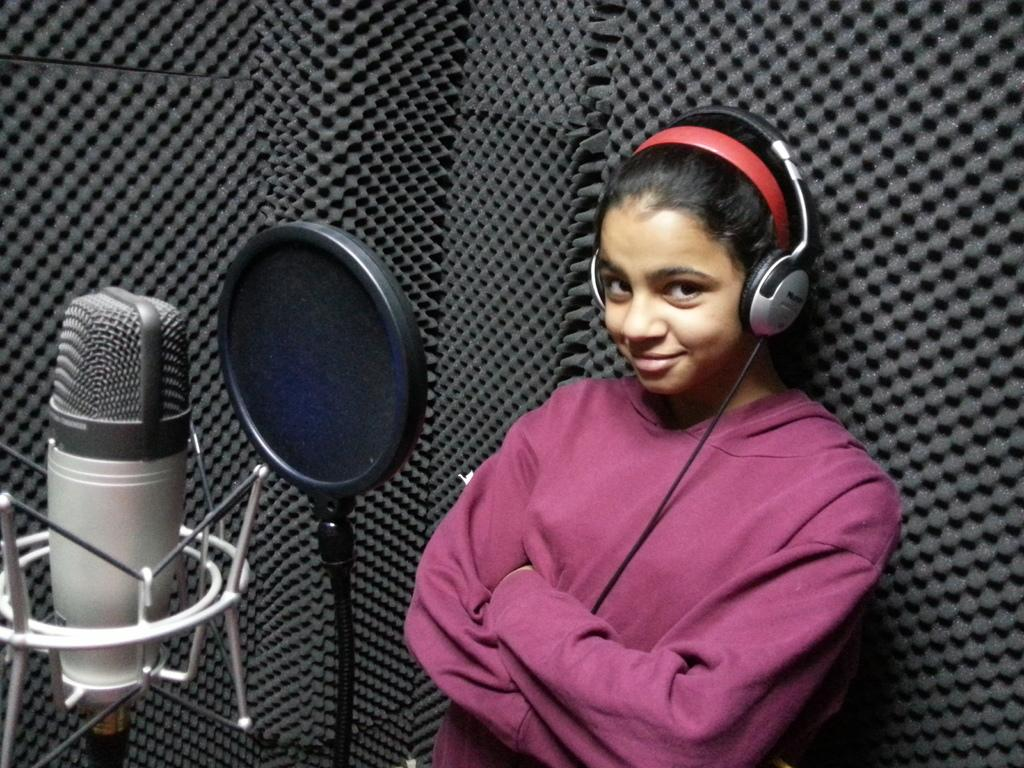Who is present in the image? There is a woman in the image. What is the woman wearing on her upper body? The woman is wearing a t-shirt. What is the woman wearing on her head? The woman is wearing a headset. What is the woman's facial expression? The woman is smiling. What is the woman looking at? The woman is looking at a picture. What can be seen on the left side of the image? There is a recording microphone on the left side of the image. What is the color of the surface in the background of the image? The surface in the background of the image is black. What type of vegetable is being chopped on the table in the image? There is no vegetable or table present in the image; it features a woman wearing a headset and looking at a picture. 